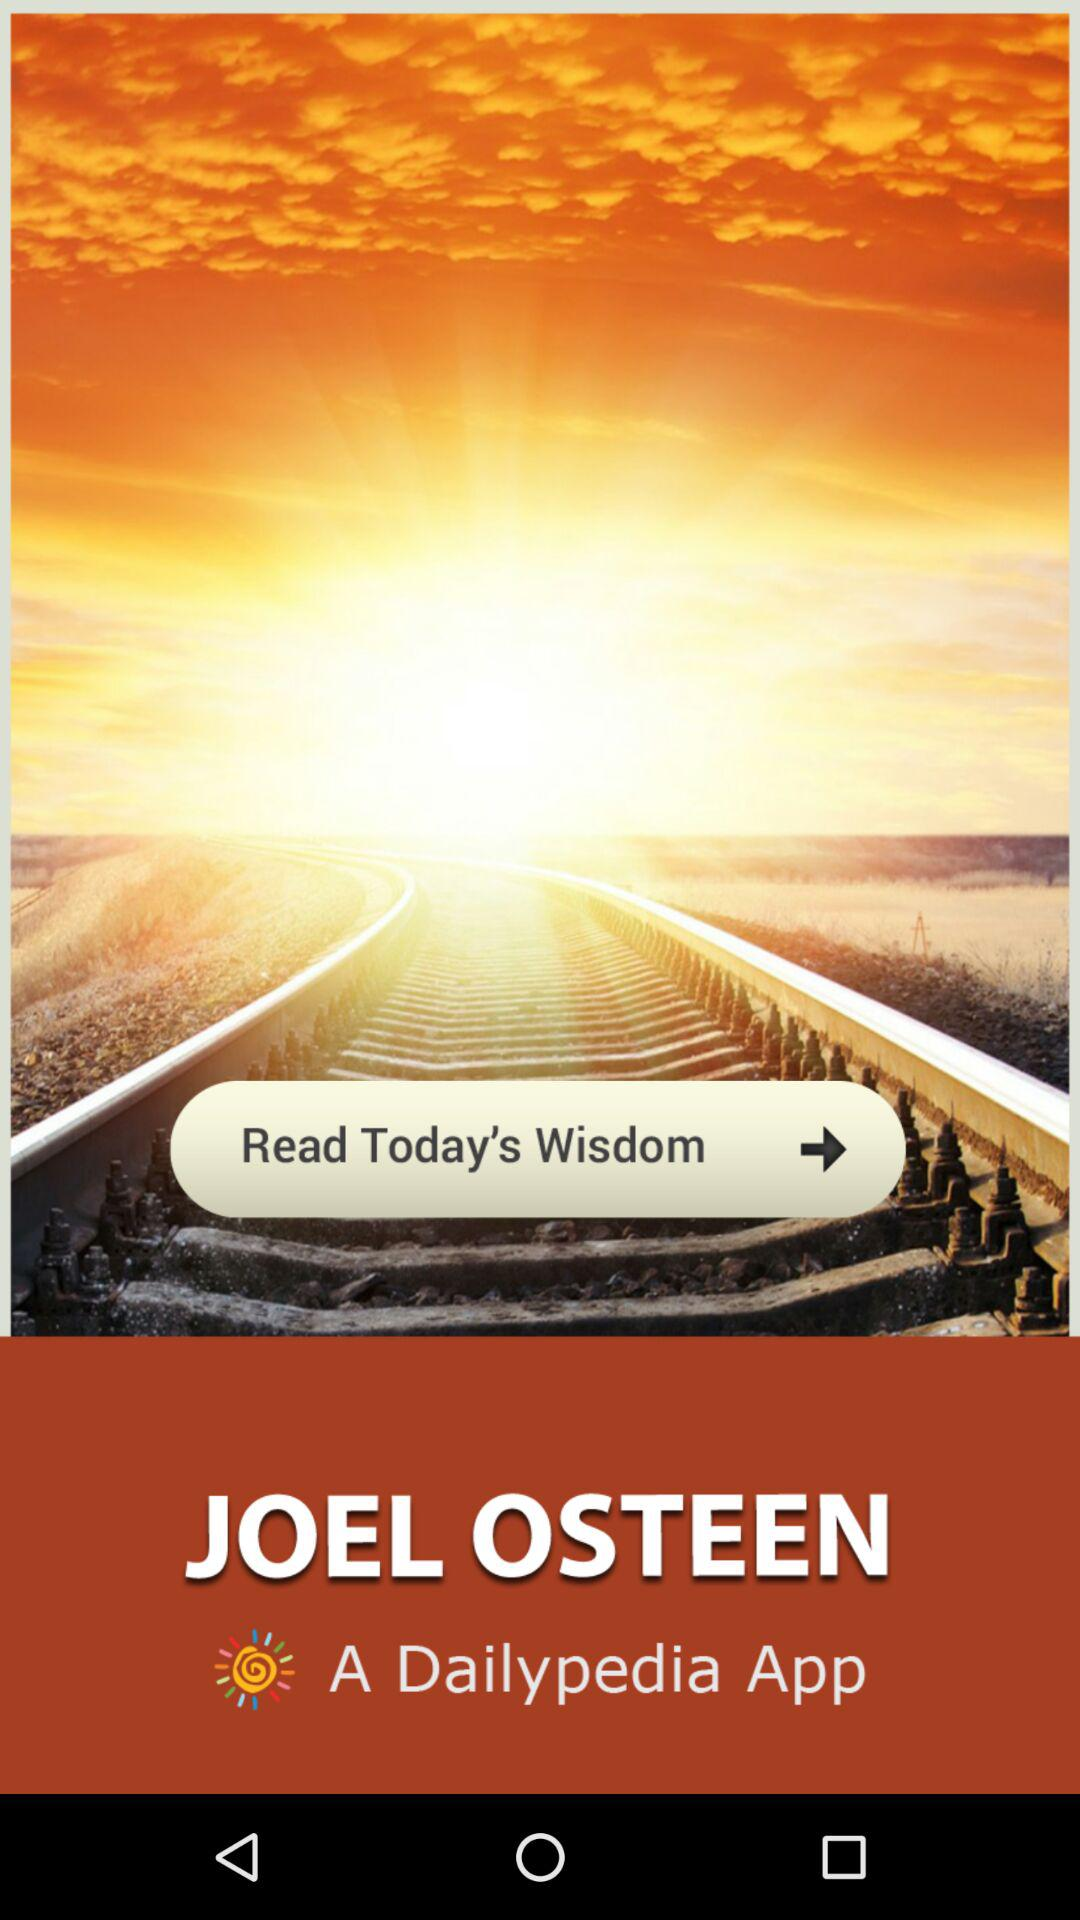What is the app name? The app name is "JOEL OSTEEN". 